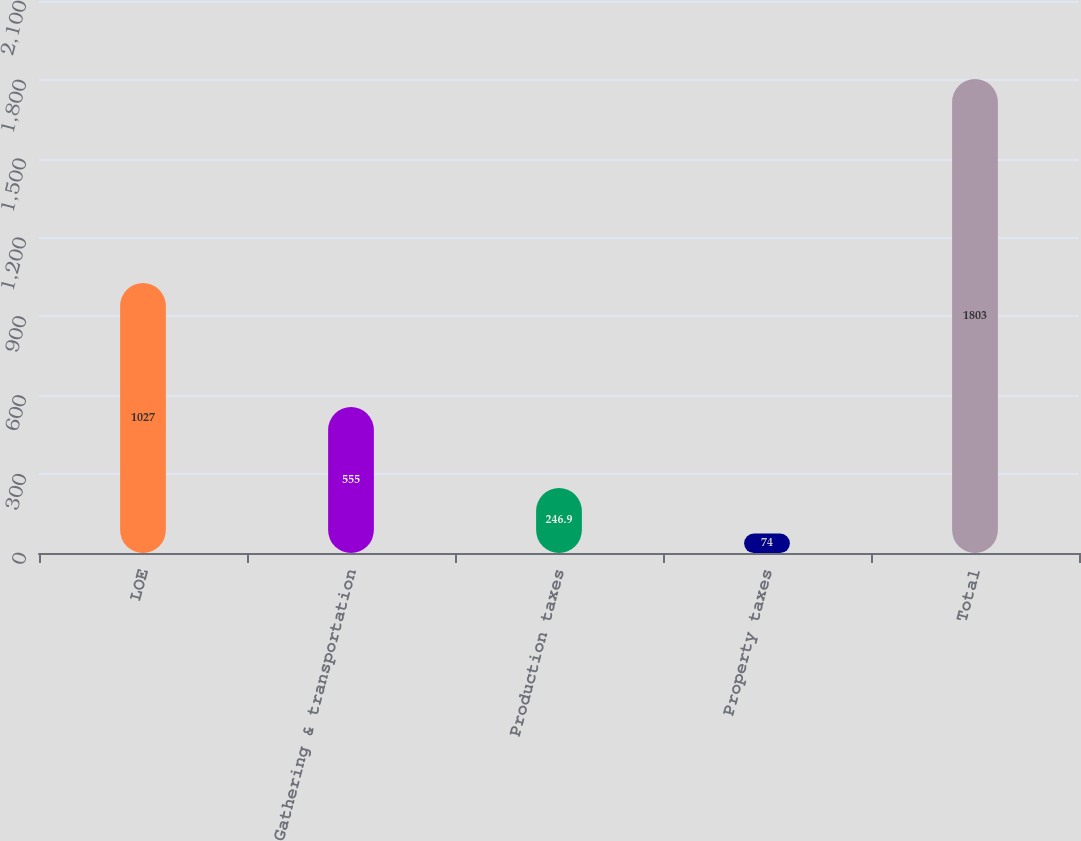<chart> <loc_0><loc_0><loc_500><loc_500><bar_chart><fcel>LOE<fcel>Gathering & transportation<fcel>Production taxes<fcel>Property taxes<fcel>Total<nl><fcel>1027<fcel>555<fcel>246.9<fcel>74<fcel>1803<nl></chart> 